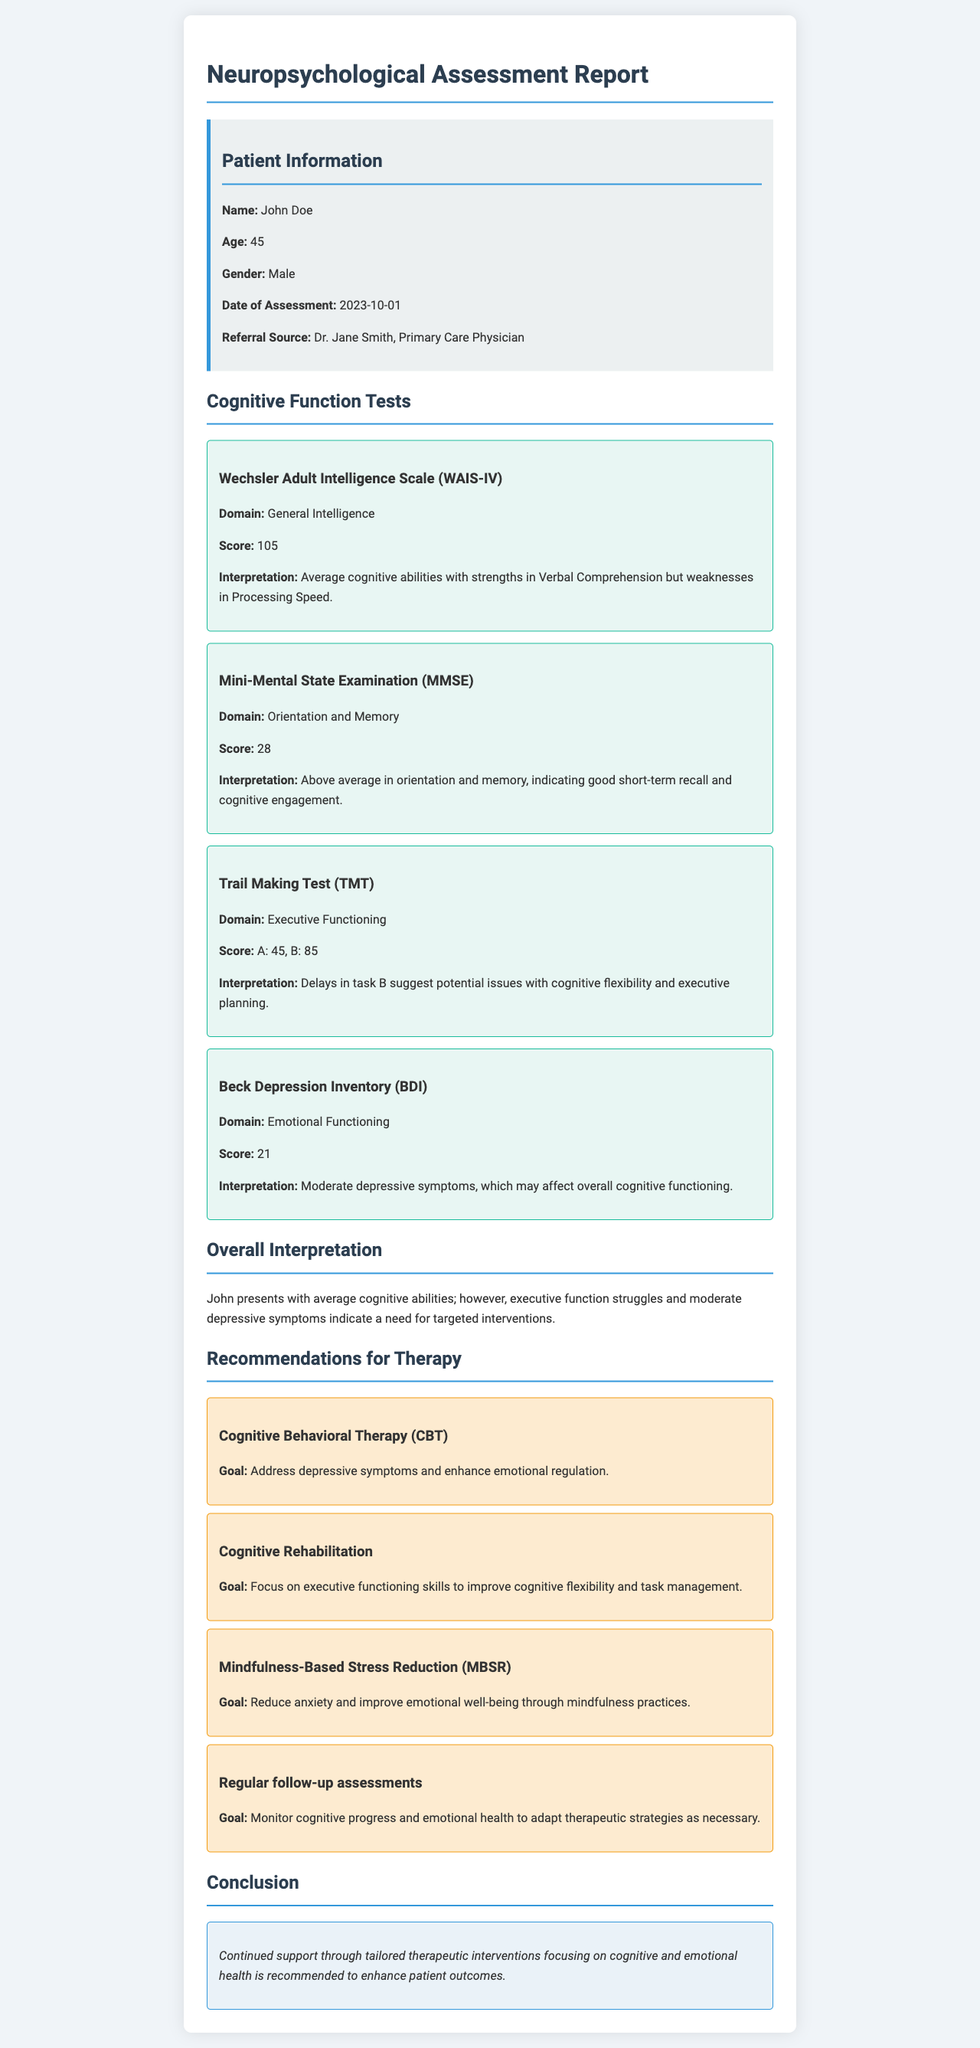What is the name of the patient? The patient's name is mentioned in the patient information section of the report.
Answer: John Doe What is the patient's age? The age of the patient is provided in the patient information section of the report.
Answer: 45 What was the score on the Mini-Mental State Examination? This score is included under the cognitive function tests of the report.
Answer: 28 What does the Beck Depression Inventory score indicate? This score reflects the patient's emotional functioning and is discussed in the test result section.
Answer: Moderate depressive symptoms What intervention focuses on cognitive flexibility? This recommendation can be found in the recommendations for therapy section of the report.
Answer: Cognitive Rehabilitation How many recommendations for therapy are provided? This information can be obtained by counting the recommendations listed in the document.
Answer: Four What cognitive domain shows strengths according to WAIS-IV? This analysis is presented under the cognitive function tests section of the report.
Answer: Verbal Comprehension What is the recommended therapy to enhance emotional regulation? This recommendation can be found in the recommendations for therapy section of the document.
Answer: Cognitive Behavioral Therapy (CBT) What is suggested to monitor cognitive progress? This is mentioned in the recommendations for therapy as an important follow-up strategy.
Answer: Regular follow-up assessments 